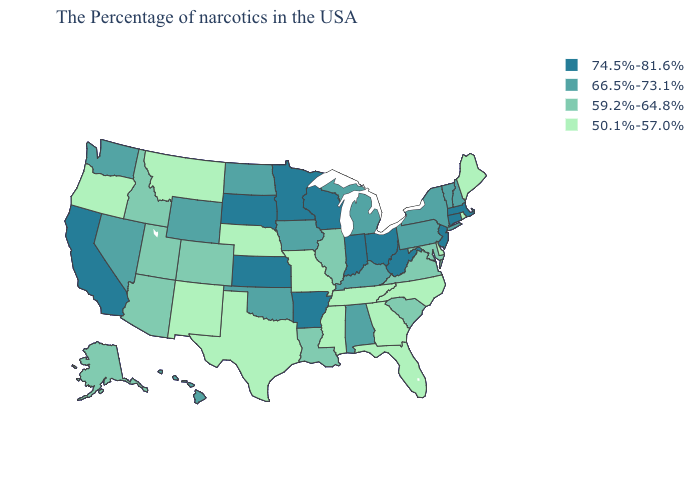Which states have the highest value in the USA?
Short answer required. Massachusetts, Connecticut, New Jersey, West Virginia, Ohio, Indiana, Wisconsin, Arkansas, Minnesota, Kansas, South Dakota, California. What is the highest value in the West ?
Be succinct. 74.5%-81.6%. What is the lowest value in the USA?
Answer briefly. 50.1%-57.0%. Which states have the highest value in the USA?
Be succinct. Massachusetts, Connecticut, New Jersey, West Virginia, Ohio, Indiana, Wisconsin, Arkansas, Minnesota, Kansas, South Dakota, California. Which states have the lowest value in the USA?
Answer briefly. Maine, Rhode Island, Delaware, North Carolina, Florida, Georgia, Tennessee, Mississippi, Missouri, Nebraska, Texas, New Mexico, Montana, Oregon. Does the map have missing data?
Concise answer only. No. Name the states that have a value in the range 50.1%-57.0%?
Write a very short answer. Maine, Rhode Island, Delaware, North Carolina, Florida, Georgia, Tennessee, Mississippi, Missouri, Nebraska, Texas, New Mexico, Montana, Oregon. What is the lowest value in the USA?
Give a very brief answer. 50.1%-57.0%. Among the states that border Mississippi , which have the highest value?
Be succinct. Arkansas. What is the value of Georgia?
Write a very short answer. 50.1%-57.0%. Among the states that border Delaware , does Maryland have the lowest value?
Give a very brief answer. Yes. Among the states that border New York , does Connecticut have the highest value?
Quick response, please. Yes. Name the states that have a value in the range 74.5%-81.6%?
Short answer required. Massachusetts, Connecticut, New Jersey, West Virginia, Ohio, Indiana, Wisconsin, Arkansas, Minnesota, Kansas, South Dakota, California. Name the states that have a value in the range 50.1%-57.0%?
Answer briefly. Maine, Rhode Island, Delaware, North Carolina, Florida, Georgia, Tennessee, Mississippi, Missouri, Nebraska, Texas, New Mexico, Montana, Oregon. 